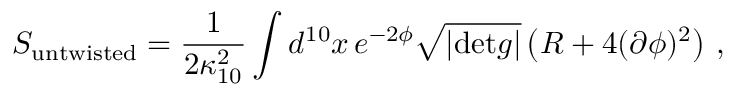Convert formula to latex. <formula><loc_0><loc_0><loc_500><loc_500>S _ { u n t w i s t e d } = \frac { 1 } { 2 \kappa _ { 1 0 } ^ { 2 } } \int d ^ { 1 0 } x \, e ^ { - 2 \phi } \sqrt { | d e t g | } \left ( R + 4 ( \partial \phi ) ^ { 2 } \right ) \, ,</formula> 